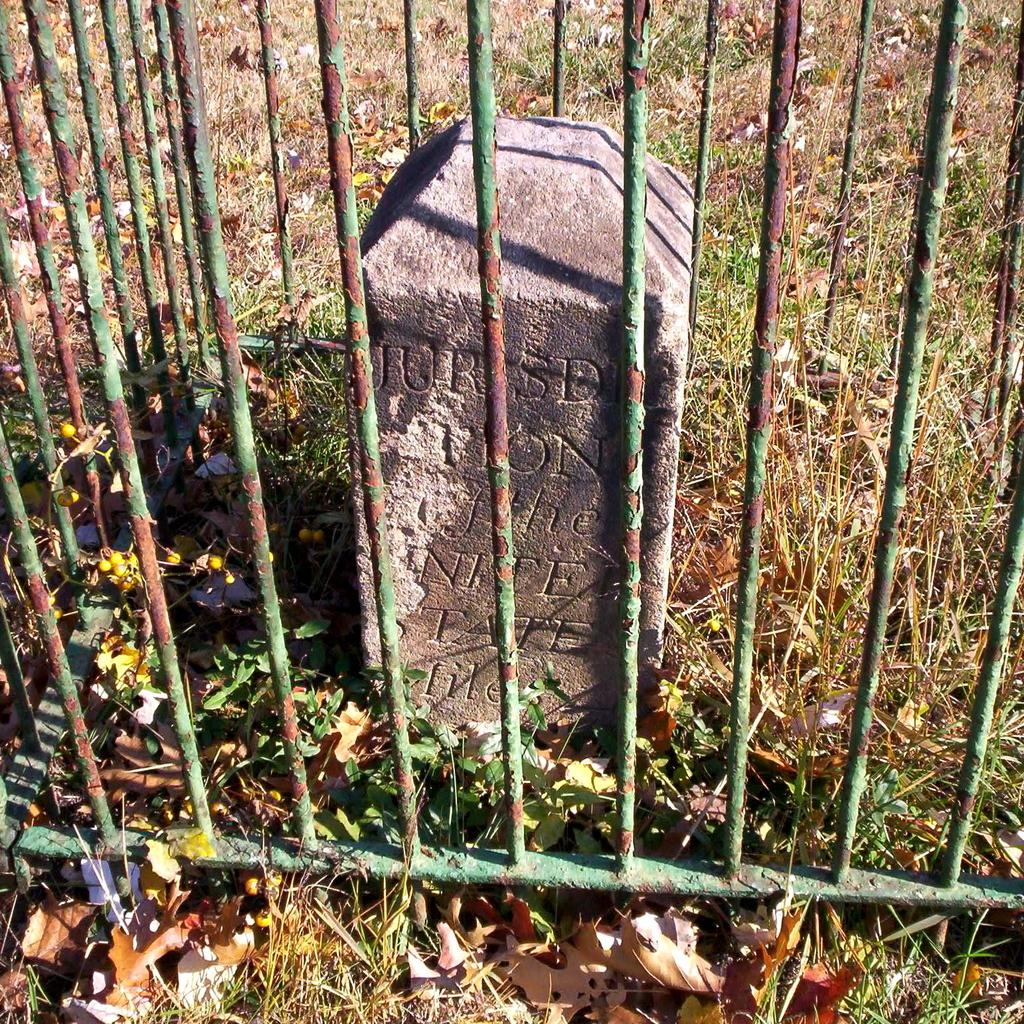What type of material is present in the image that is used for construction or security? There are iron bars in the image. What type of vegetation can be seen on the ground in the image? There are leaves on the ground in the image. What type of vegetation is growing in the image? There is grass in the image. What type of object can be found in the image that is typically found in nature? There is a stone in the image. What is written on the stone in the image? Something is written on the stone in the image. Can you see a church in the image? There is no church present in the image. Is there a plane flying in the sky in the image? There is no plane visible in the image. 